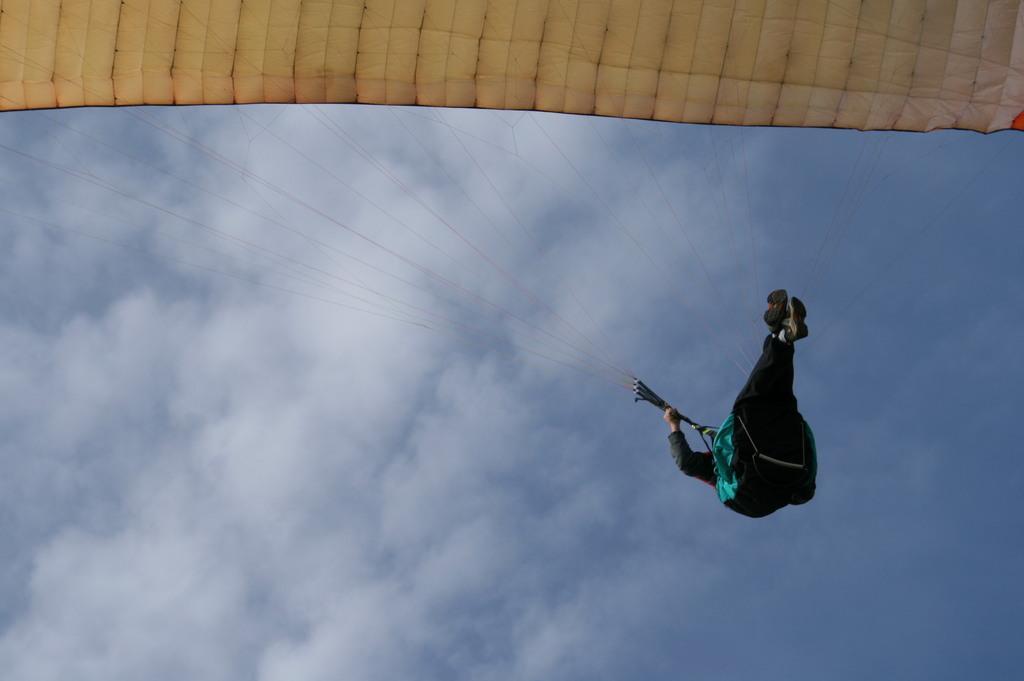Could you give a brief overview of what you see in this image? In this image, at the right side there is a person holding parachute, there is a parachute at the top, at the background there is a blue color sky and there are some white color clouds. 